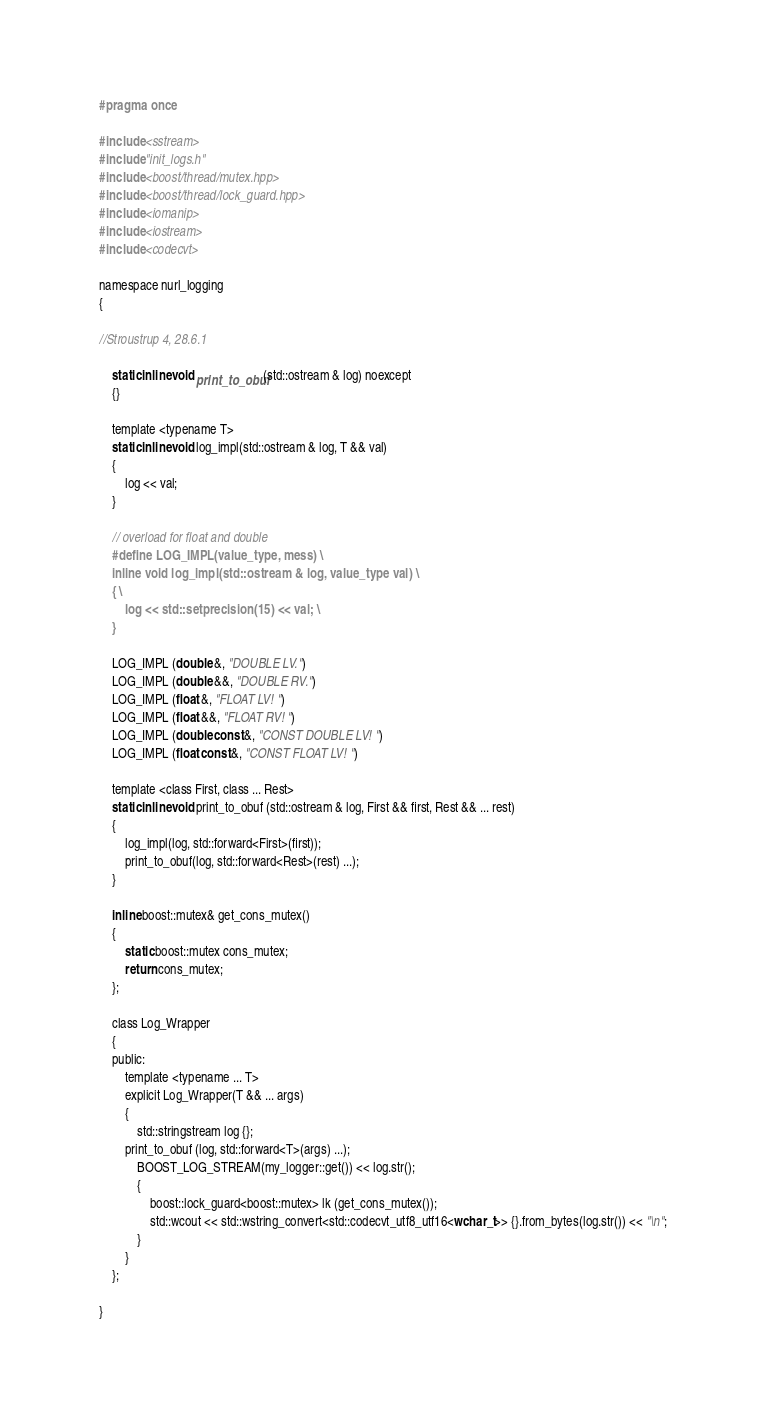<code> <loc_0><loc_0><loc_500><loc_500><_C_>#pragma once

#include <sstream>
#include "init_logs.h"
#include <boost/thread/mutex.hpp>
#include <boost/thread/lock_guard.hpp>
#include <iomanip>
#include <iostream>
#include <codecvt>

namespace nurl_logging
{

//Stroustrup 4, 28.6.1

    static inline void print_to_obuf(std::ostream & log) noexcept
    {}

    template <typename T>
    static inline void log_impl(std::ostream & log, T && val)
    {
        log << val;
    }

    // overload for float and double
    #define LOG_IMPL(value_type, mess) \
    inline void log_impl(std::ostream & log, value_type val) \
    { \
        log << std::setprecision(15) << val; \
    }

    LOG_IMPL (double &, "DOUBLE LV.")
    LOG_IMPL (double &&, "DOUBLE RV.")
    LOG_IMPL (float &, "FLOAT LV! ")
    LOG_IMPL (float &&, "FLOAT RV! ")
    LOG_IMPL (double const &, "CONST DOUBLE LV! ")
    LOG_IMPL (float const &, "CONST FLOAT LV! ")

    template <class First, class ... Rest>
    static inline void print_to_obuf (std::ostream & log, First && first, Rest && ... rest)
    {
        log_impl(log, std::forward<First>(first));
        print_to_obuf(log, std::forward<Rest>(rest) ...);
    }

    inline boost::mutex& get_cons_mutex()
    {
        static boost::mutex cons_mutex;
        return cons_mutex;
    };

    class Log_Wrapper
    {
    public:
        template <typename ... T>
        explicit Log_Wrapper(T && ... args)
        {
            std::stringstream log {};
	    print_to_obuf (log, std::forward<T>(args) ...);
            BOOST_LOG_STREAM(my_logger::get()) << log.str();
            {
                boost::lock_guard<boost::mutex> lk (get_cons_mutex());
                std::wcout << std::wstring_convert<std::codecvt_utf8_utf16<wchar_t>> {}.from_bytes(log.str()) << "\n";
            }
        }
    };

}

</code> 